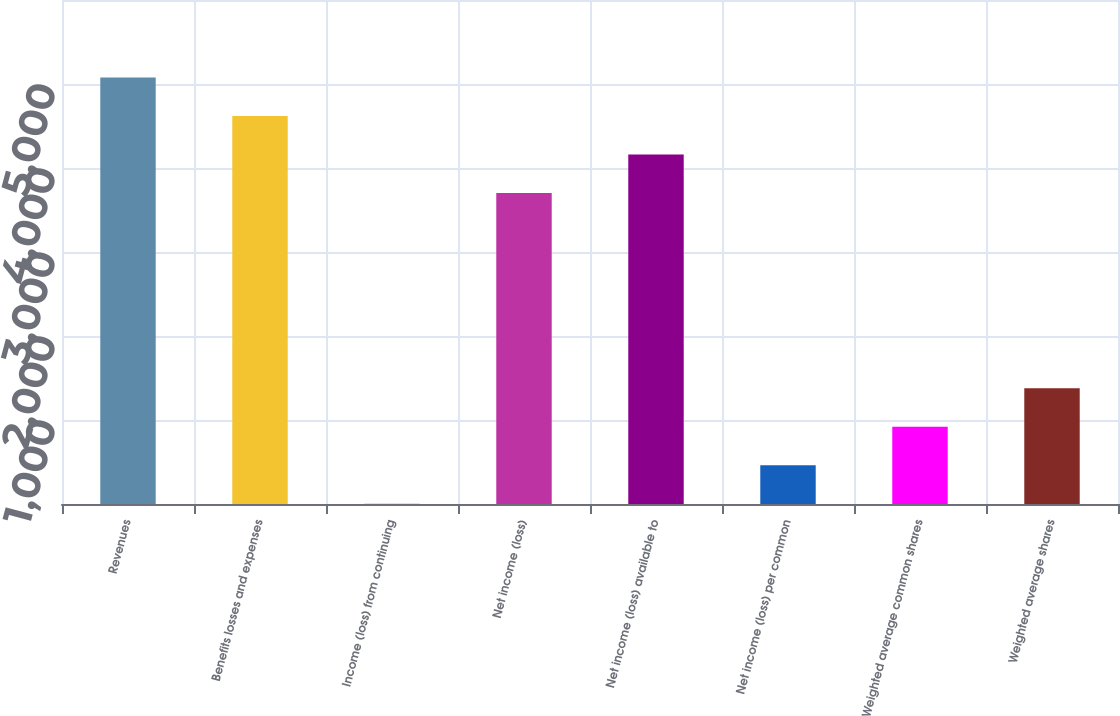<chart> <loc_0><loc_0><loc_500><loc_500><bar_chart><fcel>Revenues<fcel>Benefits losses and expenses<fcel>Income (loss) from continuing<fcel>Net income (loss)<fcel>Net income (loss) available to<fcel>Net income (loss) per common<fcel>Weighted average common shares<fcel>Weighted average shares<nl><fcel>5078.62<fcel>4620.08<fcel>1.56<fcel>3703<fcel>4161.54<fcel>460.1<fcel>918.64<fcel>1377.18<nl></chart> 